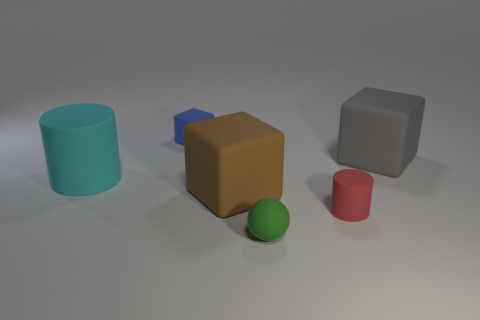How many other things are there of the same size as the blue rubber block?
Ensure brevity in your answer.  2. Do the tiny rubber object that is behind the small cylinder and the small rubber cylinder have the same color?
Your answer should be compact. No. There is a rubber thing that is behind the red object and in front of the cyan rubber thing; what size is it?
Offer a very short reply. Large. What number of big objects are either matte things or yellow shiny cylinders?
Your response must be concise. 3. What is the shape of the large matte thing that is on the right side of the matte ball?
Your response must be concise. Cube. What number of tiny blue cylinders are there?
Offer a very short reply. 0. Does the brown thing have the same material as the small sphere?
Offer a terse response. Yes. Is the number of brown cubes that are in front of the red matte thing greater than the number of small blocks?
Make the answer very short. No. How many things are either brown rubber blocks or large matte objects left of the red object?
Offer a very short reply. 2. Is the number of gray rubber objects behind the small block greater than the number of cylinders in front of the brown matte cube?
Offer a terse response. No. 